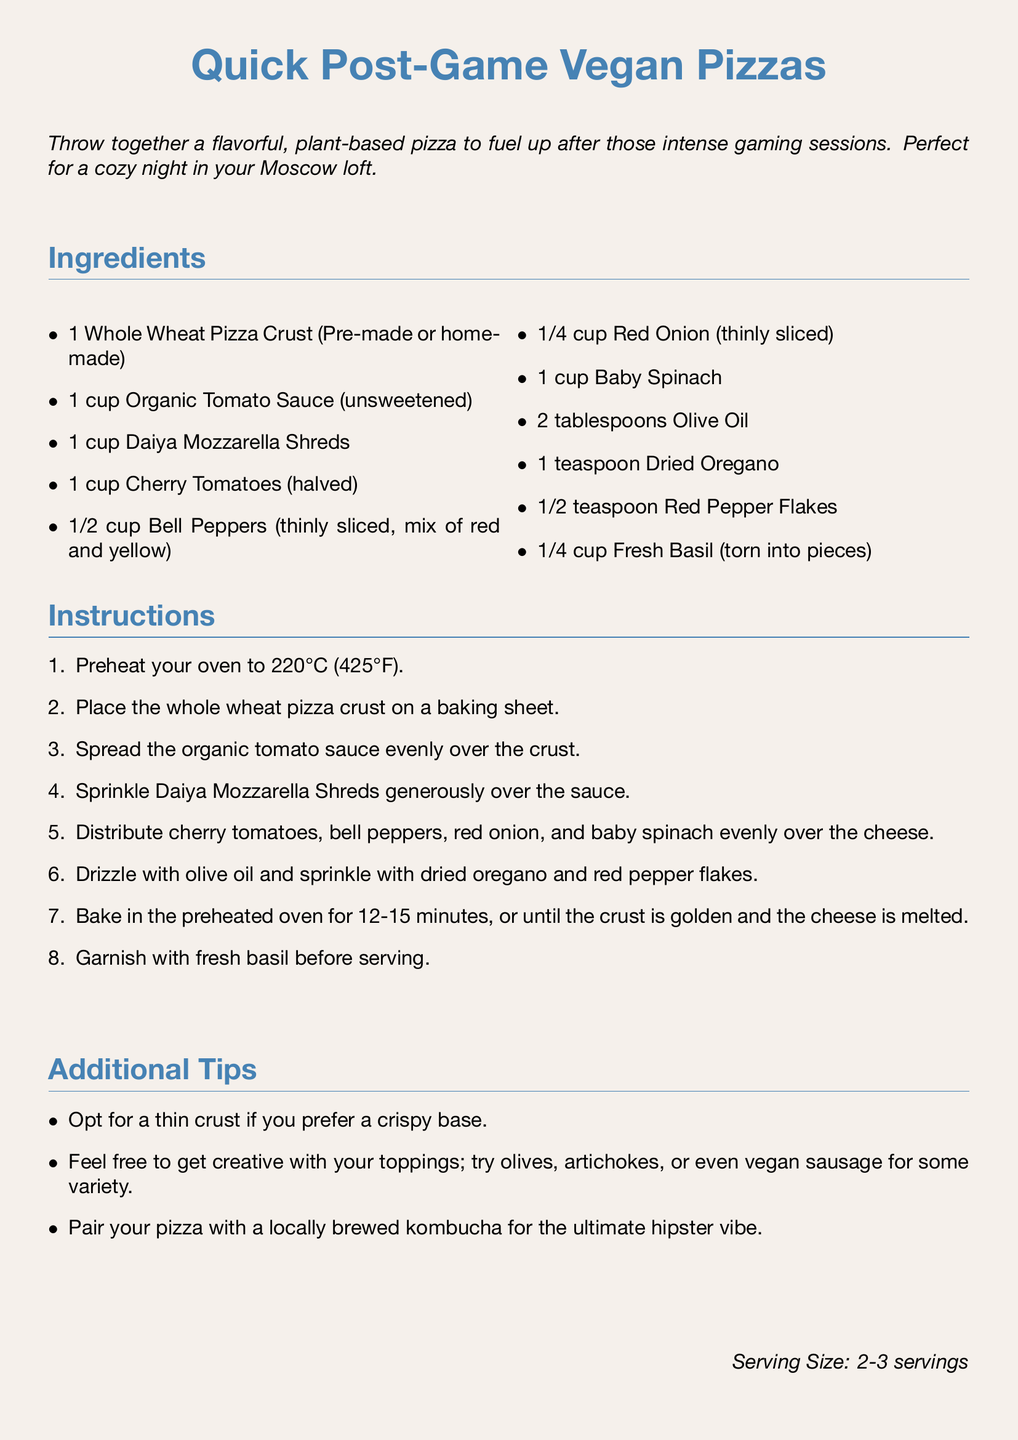What is the main ingredient for the crust? The main ingredient for the crust is described as Whole Wheat Pizza Crust in the ingredients section.
Answer: Whole Wheat Pizza Crust How long should you bake the pizza? The baking time for the pizza is mentioned in the instructions, which states to bake it for 12-15 minutes.
Answer: 12-15 minutes What type of cheese is used in the recipe? The recipe specifies the type of cheese to use, which is Daiya Mozzarella Shreds.
Answer: Daiya Mozzarella Shreds What temperature should the oven be preheated to? The document mentions the temperature to preheat the oven in the instructions, which is 220°C.
Answer: 220°C What additional toppings are suggested for creativity? The additional tips section suggests trying olives, artichokes, or vegan sausage for variety.
Answer: Olives, artichokes, or vegan sausage How many servings does this recipe yield? The serving size is provided at the end of the document, which indicates it serves 2-3.
Answer: 2-3 servings What herb is suggested for garnishing the pizza? The document specifies the herb to garnish with, which is Fresh Basil.
Answer: Fresh Basil What is a suggested drink to pair with the pizza? The additional tips mention pairing the pizza with a locally brewed kombucha.
Answer: Kombucha 